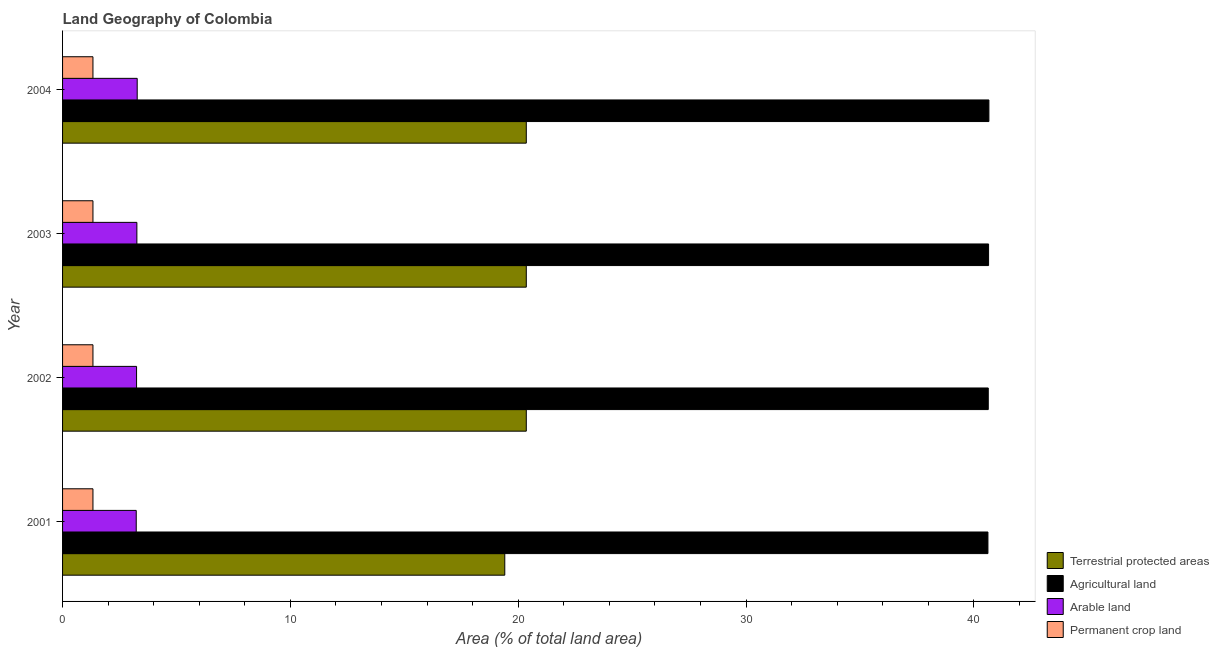How many different coloured bars are there?
Make the answer very short. 4. How many groups of bars are there?
Ensure brevity in your answer.  4. Are the number of bars per tick equal to the number of legend labels?
Your response must be concise. Yes. Are the number of bars on each tick of the Y-axis equal?
Provide a succinct answer. Yes. What is the label of the 4th group of bars from the top?
Offer a terse response. 2001. In how many cases, is the number of bars for a given year not equal to the number of legend labels?
Your answer should be very brief. 0. What is the percentage of area under arable land in 2002?
Ensure brevity in your answer.  3.25. Across all years, what is the maximum percentage of land under terrestrial protection?
Keep it short and to the point. 20.36. Across all years, what is the minimum percentage of land under terrestrial protection?
Ensure brevity in your answer.  19.41. In which year was the percentage of land under terrestrial protection maximum?
Make the answer very short. 2004. In which year was the percentage of area under agricultural land minimum?
Give a very brief answer. 2001. What is the total percentage of land under terrestrial protection in the graph?
Offer a very short reply. 80.48. What is the difference between the percentage of area under arable land in 2002 and that in 2003?
Ensure brevity in your answer.  -0.01. What is the difference between the percentage of area under arable land in 2003 and the percentage of land under terrestrial protection in 2002?
Your response must be concise. -17.09. What is the average percentage of area under permanent crop land per year?
Provide a succinct answer. 1.33. In the year 2003, what is the difference between the percentage of area under arable land and percentage of area under agricultural land?
Offer a terse response. -37.39. In how many years, is the percentage of area under permanent crop land greater than 38 %?
Offer a terse response. 0. Is the difference between the percentage of area under agricultural land in 2002 and 2004 greater than the difference between the percentage of area under permanent crop land in 2002 and 2004?
Your response must be concise. No. What is the difference between the highest and the second highest percentage of land under terrestrial protection?
Ensure brevity in your answer.  0. What is the difference between the highest and the lowest percentage of land under terrestrial protection?
Make the answer very short. 0.94. Is the sum of the percentage of area under arable land in 2001 and 2003 greater than the maximum percentage of area under permanent crop land across all years?
Ensure brevity in your answer.  Yes. What does the 1st bar from the top in 2001 represents?
Make the answer very short. Permanent crop land. What does the 4th bar from the bottom in 2002 represents?
Ensure brevity in your answer.  Permanent crop land. How many years are there in the graph?
Make the answer very short. 4. Does the graph contain any zero values?
Your response must be concise. No. Does the graph contain grids?
Provide a succinct answer. No. How many legend labels are there?
Provide a short and direct response. 4. How are the legend labels stacked?
Your answer should be compact. Vertical. What is the title of the graph?
Provide a short and direct response. Land Geography of Colombia. Does "Water" appear as one of the legend labels in the graph?
Your answer should be compact. No. What is the label or title of the X-axis?
Make the answer very short. Area (% of total land area). What is the Area (% of total land area) of Terrestrial protected areas in 2001?
Your answer should be compact. 19.41. What is the Area (% of total land area) of Agricultural land in 2001?
Your answer should be very brief. 40.62. What is the Area (% of total land area) of Arable land in 2001?
Provide a short and direct response. 3.23. What is the Area (% of total land area) in Permanent crop land in 2001?
Provide a succinct answer. 1.33. What is the Area (% of total land area) in Terrestrial protected areas in 2002?
Your response must be concise. 20.36. What is the Area (% of total land area) of Agricultural land in 2002?
Your response must be concise. 40.63. What is the Area (% of total land area) in Arable land in 2002?
Your answer should be compact. 3.25. What is the Area (% of total land area) in Permanent crop land in 2002?
Your answer should be very brief. 1.33. What is the Area (% of total land area) of Terrestrial protected areas in 2003?
Give a very brief answer. 20.36. What is the Area (% of total land area) of Agricultural land in 2003?
Provide a succinct answer. 40.65. What is the Area (% of total land area) of Arable land in 2003?
Ensure brevity in your answer.  3.26. What is the Area (% of total land area) in Permanent crop land in 2003?
Keep it short and to the point. 1.33. What is the Area (% of total land area) in Terrestrial protected areas in 2004?
Make the answer very short. 20.36. What is the Area (% of total land area) in Agricultural land in 2004?
Keep it short and to the point. 40.66. What is the Area (% of total land area) of Arable land in 2004?
Provide a succinct answer. 3.28. What is the Area (% of total land area) in Permanent crop land in 2004?
Make the answer very short. 1.33. Across all years, what is the maximum Area (% of total land area) in Terrestrial protected areas?
Offer a terse response. 20.36. Across all years, what is the maximum Area (% of total land area) of Agricultural land?
Your answer should be compact. 40.66. Across all years, what is the maximum Area (% of total land area) in Arable land?
Your response must be concise. 3.28. Across all years, what is the maximum Area (% of total land area) in Permanent crop land?
Your answer should be very brief. 1.33. Across all years, what is the minimum Area (% of total land area) of Terrestrial protected areas?
Offer a terse response. 19.41. Across all years, what is the minimum Area (% of total land area) in Agricultural land?
Keep it short and to the point. 40.62. Across all years, what is the minimum Area (% of total land area) of Arable land?
Give a very brief answer. 3.23. Across all years, what is the minimum Area (% of total land area) in Permanent crop land?
Ensure brevity in your answer.  1.33. What is the total Area (% of total land area) in Terrestrial protected areas in the graph?
Ensure brevity in your answer.  80.48. What is the total Area (% of total land area) in Agricultural land in the graph?
Make the answer very short. 162.57. What is the total Area (% of total land area) in Arable land in the graph?
Your answer should be very brief. 13.02. What is the total Area (% of total land area) of Permanent crop land in the graph?
Your response must be concise. 5.34. What is the difference between the Area (% of total land area) in Terrestrial protected areas in 2001 and that in 2002?
Provide a short and direct response. -0.94. What is the difference between the Area (% of total land area) of Agricultural land in 2001 and that in 2002?
Your answer should be compact. -0.01. What is the difference between the Area (% of total land area) in Arable land in 2001 and that in 2002?
Your answer should be compact. -0.01. What is the difference between the Area (% of total land area) of Terrestrial protected areas in 2001 and that in 2003?
Your answer should be compact. -0.94. What is the difference between the Area (% of total land area) in Agricultural land in 2001 and that in 2003?
Your answer should be compact. -0.03. What is the difference between the Area (% of total land area) of Arable land in 2001 and that in 2003?
Ensure brevity in your answer.  -0.03. What is the difference between the Area (% of total land area) of Permanent crop land in 2001 and that in 2003?
Offer a very short reply. 0. What is the difference between the Area (% of total land area) in Terrestrial protected areas in 2001 and that in 2004?
Keep it short and to the point. -0.94. What is the difference between the Area (% of total land area) of Agricultural land in 2001 and that in 2004?
Offer a very short reply. -0.04. What is the difference between the Area (% of total land area) of Arable land in 2001 and that in 2004?
Provide a short and direct response. -0.04. What is the difference between the Area (% of total land area) of Terrestrial protected areas in 2002 and that in 2003?
Keep it short and to the point. 0. What is the difference between the Area (% of total land area) of Agricultural land in 2002 and that in 2003?
Your response must be concise. -0.01. What is the difference between the Area (% of total land area) of Arable land in 2002 and that in 2003?
Provide a succinct answer. -0.01. What is the difference between the Area (% of total land area) of Permanent crop land in 2002 and that in 2003?
Offer a very short reply. 0. What is the difference between the Area (% of total land area) of Agricultural land in 2002 and that in 2004?
Give a very brief answer. -0.03. What is the difference between the Area (% of total land area) of Arable land in 2002 and that in 2004?
Provide a succinct answer. -0.03. What is the difference between the Area (% of total land area) in Agricultural land in 2003 and that in 2004?
Offer a very short reply. -0.01. What is the difference between the Area (% of total land area) of Arable land in 2003 and that in 2004?
Make the answer very short. -0.01. What is the difference between the Area (% of total land area) in Terrestrial protected areas in 2001 and the Area (% of total land area) in Agricultural land in 2002?
Offer a terse response. -21.22. What is the difference between the Area (% of total land area) of Terrestrial protected areas in 2001 and the Area (% of total land area) of Arable land in 2002?
Make the answer very short. 16.16. What is the difference between the Area (% of total land area) of Terrestrial protected areas in 2001 and the Area (% of total land area) of Permanent crop land in 2002?
Keep it short and to the point. 18.08. What is the difference between the Area (% of total land area) in Agricultural land in 2001 and the Area (% of total land area) in Arable land in 2002?
Your answer should be very brief. 37.37. What is the difference between the Area (% of total land area) of Agricultural land in 2001 and the Area (% of total land area) of Permanent crop land in 2002?
Ensure brevity in your answer.  39.29. What is the difference between the Area (% of total land area) of Terrestrial protected areas in 2001 and the Area (% of total land area) of Agricultural land in 2003?
Make the answer very short. -21.24. What is the difference between the Area (% of total land area) of Terrestrial protected areas in 2001 and the Area (% of total land area) of Arable land in 2003?
Provide a succinct answer. 16.15. What is the difference between the Area (% of total land area) in Terrestrial protected areas in 2001 and the Area (% of total land area) in Permanent crop land in 2003?
Provide a short and direct response. 18.08. What is the difference between the Area (% of total land area) of Agricultural land in 2001 and the Area (% of total land area) of Arable land in 2003?
Offer a terse response. 37.36. What is the difference between the Area (% of total land area) in Agricultural land in 2001 and the Area (% of total land area) in Permanent crop land in 2003?
Give a very brief answer. 39.29. What is the difference between the Area (% of total land area) of Terrestrial protected areas in 2001 and the Area (% of total land area) of Agricultural land in 2004?
Give a very brief answer. -21.25. What is the difference between the Area (% of total land area) in Terrestrial protected areas in 2001 and the Area (% of total land area) in Arable land in 2004?
Your answer should be very brief. 16.13. What is the difference between the Area (% of total land area) of Terrestrial protected areas in 2001 and the Area (% of total land area) of Permanent crop land in 2004?
Your answer should be very brief. 18.08. What is the difference between the Area (% of total land area) in Agricultural land in 2001 and the Area (% of total land area) in Arable land in 2004?
Your answer should be very brief. 37.34. What is the difference between the Area (% of total land area) of Agricultural land in 2001 and the Area (% of total land area) of Permanent crop land in 2004?
Offer a very short reply. 39.29. What is the difference between the Area (% of total land area) of Arable land in 2001 and the Area (% of total land area) of Permanent crop land in 2004?
Give a very brief answer. 1.9. What is the difference between the Area (% of total land area) in Terrestrial protected areas in 2002 and the Area (% of total land area) in Agricultural land in 2003?
Provide a succinct answer. -20.29. What is the difference between the Area (% of total land area) of Terrestrial protected areas in 2002 and the Area (% of total land area) of Arable land in 2003?
Your response must be concise. 17.09. What is the difference between the Area (% of total land area) in Terrestrial protected areas in 2002 and the Area (% of total land area) in Permanent crop land in 2003?
Your response must be concise. 19.02. What is the difference between the Area (% of total land area) in Agricultural land in 2002 and the Area (% of total land area) in Arable land in 2003?
Your answer should be very brief. 37.37. What is the difference between the Area (% of total land area) of Agricultural land in 2002 and the Area (% of total land area) of Permanent crop land in 2003?
Your answer should be very brief. 39.3. What is the difference between the Area (% of total land area) in Arable land in 2002 and the Area (% of total land area) in Permanent crop land in 2003?
Ensure brevity in your answer.  1.91. What is the difference between the Area (% of total land area) of Terrestrial protected areas in 2002 and the Area (% of total land area) of Agricultural land in 2004?
Ensure brevity in your answer.  -20.31. What is the difference between the Area (% of total land area) of Terrestrial protected areas in 2002 and the Area (% of total land area) of Arable land in 2004?
Your answer should be very brief. 17.08. What is the difference between the Area (% of total land area) in Terrestrial protected areas in 2002 and the Area (% of total land area) in Permanent crop land in 2004?
Give a very brief answer. 19.02. What is the difference between the Area (% of total land area) of Agricultural land in 2002 and the Area (% of total land area) of Arable land in 2004?
Your response must be concise. 37.36. What is the difference between the Area (% of total land area) of Agricultural land in 2002 and the Area (% of total land area) of Permanent crop land in 2004?
Provide a short and direct response. 39.3. What is the difference between the Area (% of total land area) of Arable land in 2002 and the Area (% of total land area) of Permanent crop land in 2004?
Your response must be concise. 1.91. What is the difference between the Area (% of total land area) in Terrestrial protected areas in 2003 and the Area (% of total land area) in Agricultural land in 2004?
Offer a terse response. -20.31. What is the difference between the Area (% of total land area) in Terrestrial protected areas in 2003 and the Area (% of total land area) in Arable land in 2004?
Give a very brief answer. 17.08. What is the difference between the Area (% of total land area) of Terrestrial protected areas in 2003 and the Area (% of total land area) of Permanent crop land in 2004?
Your response must be concise. 19.02. What is the difference between the Area (% of total land area) in Agricultural land in 2003 and the Area (% of total land area) in Arable land in 2004?
Your response must be concise. 37.37. What is the difference between the Area (% of total land area) in Agricultural land in 2003 and the Area (% of total land area) in Permanent crop land in 2004?
Keep it short and to the point. 39.31. What is the difference between the Area (% of total land area) in Arable land in 2003 and the Area (% of total land area) in Permanent crop land in 2004?
Your response must be concise. 1.93. What is the average Area (% of total land area) in Terrestrial protected areas per year?
Offer a very short reply. 20.12. What is the average Area (% of total land area) of Agricultural land per year?
Offer a terse response. 40.64. What is the average Area (% of total land area) in Arable land per year?
Your answer should be very brief. 3.26. What is the average Area (% of total land area) of Permanent crop land per year?
Ensure brevity in your answer.  1.33. In the year 2001, what is the difference between the Area (% of total land area) of Terrestrial protected areas and Area (% of total land area) of Agricultural land?
Your answer should be compact. -21.21. In the year 2001, what is the difference between the Area (% of total land area) of Terrestrial protected areas and Area (% of total land area) of Arable land?
Make the answer very short. 16.18. In the year 2001, what is the difference between the Area (% of total land area) in Terrestrial protected areas and Area (% of total land area) in Permanent crop land?
Offer a very short reply. 18.08. In the year 2001, what is the difference between the Area (% of total land area) in Agricultural land and Area (% of total land area) in Arable land?
Your answer should be very brief. 37.39. In the year 2001, what is the difference between the Area (% of total land area) in Agricultural land and Area (% of total land area) in Permanent crop land?
Make the answer very short. 39.29. In the year 2001, what is the difference between the Area (% of total land area) of Arable land and Area (% of total land area) of Permanent crop land?
Ensure brevity in your answer.  1.9. In the year 2002, what is the difference between the Area (% of total land area) of Terrestrial protected areas and Area (% of total land area) of Agricultural land?
Offer a very short reply. -20.28. In the year 2002, what is the difference between the Area (% of total land area) in Terrestrial protected areas and Area (% of total land area) in Arable land?
Offer a terse response. 17.11. In the year 2002, what is the difference between the Area (% of total land area) of Terrestrial protected areas and Area (% of total land area) of Permanent crop land?
Your response must be concise. 19.02. In the year 2002, what is the difference between the Area (% of total land area) of Agricultural land and Area (% of total land area) of Arable land?
Offer a very short reply. 37.39. In the year 2002, what is the difference between the Area (% of total land area) in Agricultural land and Area (% of total land area) in Permanent crop land?
Keep it short and to the point. 39.3. In the year 2002, what is the difference between the Area (% of total land area) in Arable land and Area (% of total land area) in Permanent crop land?
Offer a very short reply. 1.91. In the year 2003, what is the difference between the Area (% of total land area) in Terrestrial protected areas and Area (% of total land area) in Agricultural land?
Ensure brevity in your answer.  -20.29. In the year 2003, what is the difference between the Area (% of total land area) in Terrestrial protected areas and Area (% of total land area) in Arable land?
Provide a succinct answer. 17.09. In the year 2003, what is the difference between the Area (% of total land area) in Terrestrial protected areas and Area (% of total land area) in Permanent crop land?
Your answer should be compact. 19.02. In the year 2003, what is the difference between the Area (% of total land area) in Agricultural land and Area (% of total land area) in Arable land?
Offer a very short reply. 37.39. In the year 2003, what is the difference between the Area (% of total land area) in Agricultural land and Area (% of total land area) in Permanent crop land?
Provide a short and direct response. 39.31. In the year 2003, what is the difference between the Area (% of total land area) of Arable land and Area (% of total land area) of Permanent crop land?
Provide a short and direct response. 1.93. In the year 2004, what is the difference between the Area (% of total land area) of Terrestrial protected areas and Area (% of total land area) of Agricultural land?
Keep it short and to the point. -20.31. In the year 2004, what is the difference between the Area (% of total land area) in Terrestrial protected areas and Area (% of total land area) in Arable land?
Ensure brevity in your answer.  17.08. In the year 2004, what is the difference between the Area (% of total land area) of Terrestrial protected areas and Area (% of total land area) of Permanent crop land?
Make the answer very short. 19.02. In the year 2004, what is the difference between the Area (% of total land area) of Agricultural land and Area (% of total land area) of Arable land?
Your answer should be compact. 37.39. In the year 2004, what is the difference between the Area (% of total land area) of Agricultural land and Area (% of total land area) of Permanent crop land?
Make the answer very short. 39.33. In the year 2004, what is the difference between the Area (% of total land area) of Arable land and Area (% of total land area) of Permanent crop land?
Provide a short and direct response. 1.94. What is the ratio of the Area (% of total land area) in Terrestrial protected areas in 2001 to that in 2002?
Ensure brevity in your answer.  0.95. What is the ratio of the Area (% of total land area) of Permanent crop land in 2001 to that in 2002?
Keep it short and to the point. 1. What is the ratio of the Area (% of total land area) in Terrestrial protected areas in 2001 to that in 2003?
Make the answer very short. 0.95. What is the ratio of the Area (% of total land area) in Agricultural land in 2001 to that in 2003?
Make the answer very short. 1. What is the ratio of the Area (% of total land area) in Terrestrial protected areas in 2001 to that in 2004?
Provide a short and direct response. 0.95. What is the ratio of the Area (% of total land area) in Agricultural land in 2001 to that in 2004?
Provide a succinct answer. 1. What is the ratio of the Area (% of total land area) of Arable land in 2001 to that in 2004?
Your response must be concise. 0.99. What is the ratio of the Area (% of total land area) in Permanent crop land in 2001 to that in 2004?
Ensure brevity in your answer.  1. What is the ratio of the Area (% of total land area) in Arable land in 2002 to that in 2003?
Your response must be concise. 1. What is the ratio of the Area (% of total land area) of Permanent crop land in 2002 to that in 2003?
Offer a very short reply. 1. What is the ratio of the Area (% of total land area) of Agricultural land in 2002 to that in 2004?
Keep it short and to the point. 1. What is the ratio of the Area (% of total land area) in Permanent crop land in 2002 to that in 2004?
Your answer should be compact. 1. What is the ratio of the Area (% of total land area) in Agricultural land in 2003 to that in 2004?
Your answer should be compact. 1. What is the ratio of the Area (% of total land area) of Arable land in 2003 to that in 2004?
Your answer should be compact. 1. What is the ratio of the Area (% of total land area) in Permanent crop land in 2003 to that in 2004?
Make the answer very short. 1. What is the difference between the highest and the second highest Area (% of total land area) in Agricultural land?
Your response must be concise. 0.01. What is the difference between the highest and the second highest Area (% of total land area) in Arable land?
Provide a succinct answer. 0.01. What is the difference between the highest and the second highest Area (% of total land area) of Permanent crop land?
Provide a short and direct response. 0. What is the difference between the highest and the lowest Area (% of total land area) of Terrestrial protected areas?
Give a very brief answer. 0.94. What is the difference between the highest and the lowest Area (% of total land area) in Agricultural land?
Your response must be concise. 0.04. What is the difference between the highest and the lowest Area (% of total land area) in Arable land?
Your response must be concise. 0.04. 